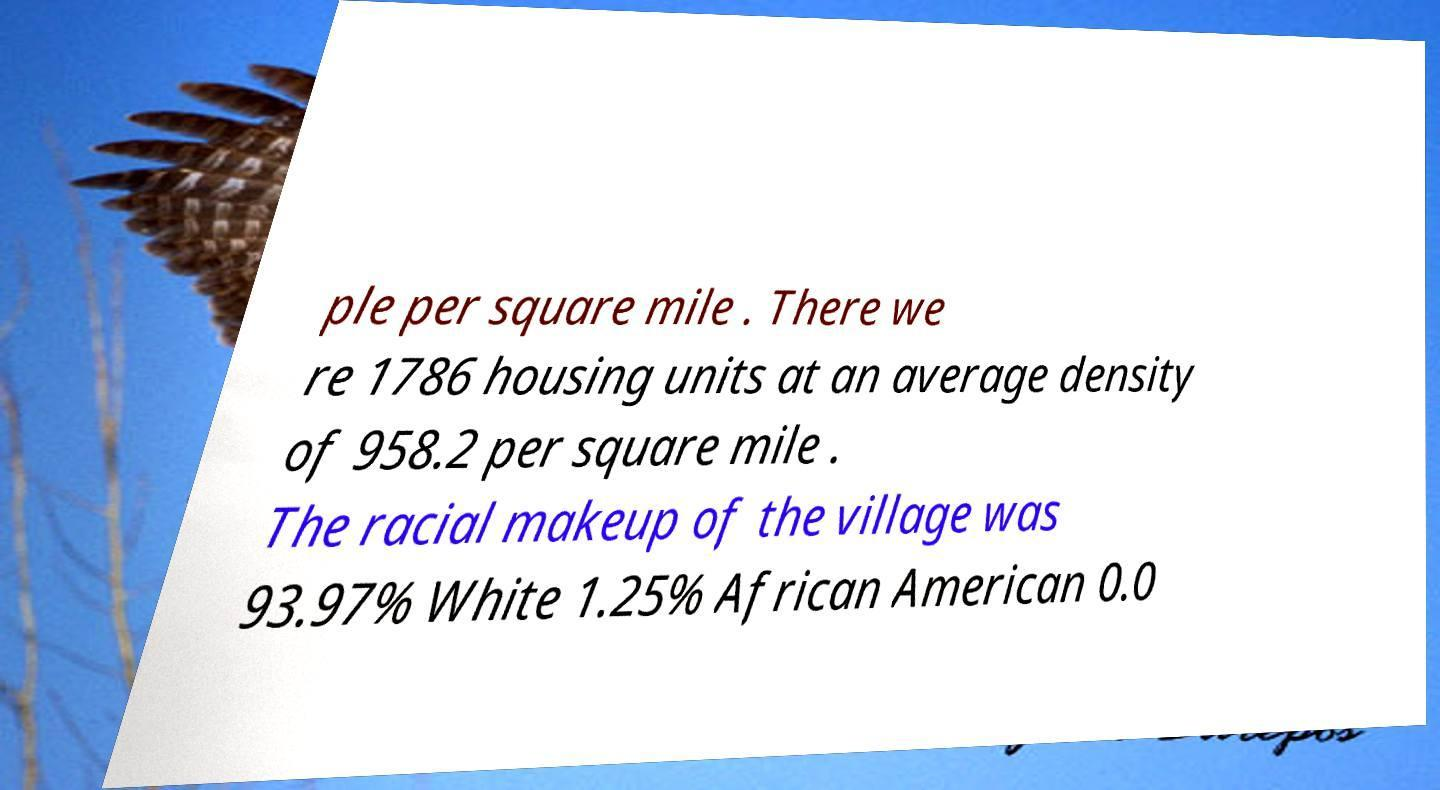Could you assist in decoding the text presented in this image and type it out clearly? ple per square mile . There we re 1786 housing units at an average density of 958.2 per square mile . The racial makeup of the village was 93.97% White 1.25% African American 0.0 